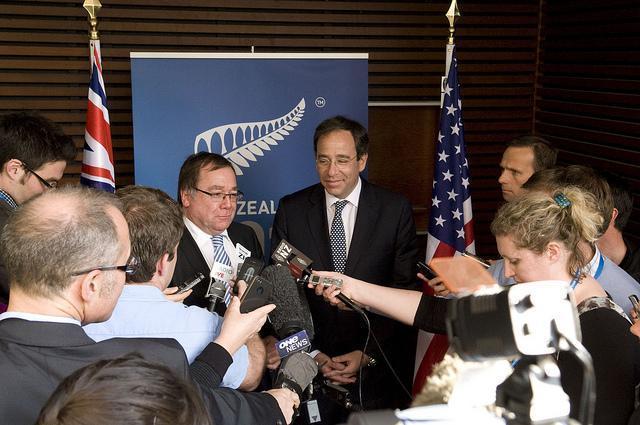How many flags are there?
Give a very brief answer. 2. How many people can be seen?
Give a very brief answer. 9. 